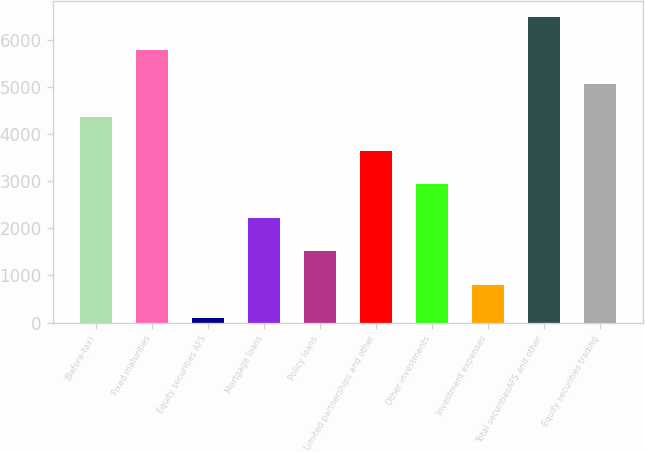Convert chart to OTSL. <chart><loc_0><loc_0><loc_500><loc_500><bar_chart><fcel>(Before-tax)<fcel>Fixed maturities<fcel>Equity securities AFS<fcel>Mortgage loans<fcel>Policy loans<fcel>Limited partnerships and other<fcel>Other investments<fcel>Investment expenses<fcel>Total securitiesAFS and other<fcel>Equity securities trading<nl><fcel>4360.2<fcel>5782.6<fcel>93<fcel>2226.6<fcel>1515.4<fcel>3649<fcel>2937.8<fcel>804.2<fcel>6493.8<fcel>5071.4<nl></chart> 